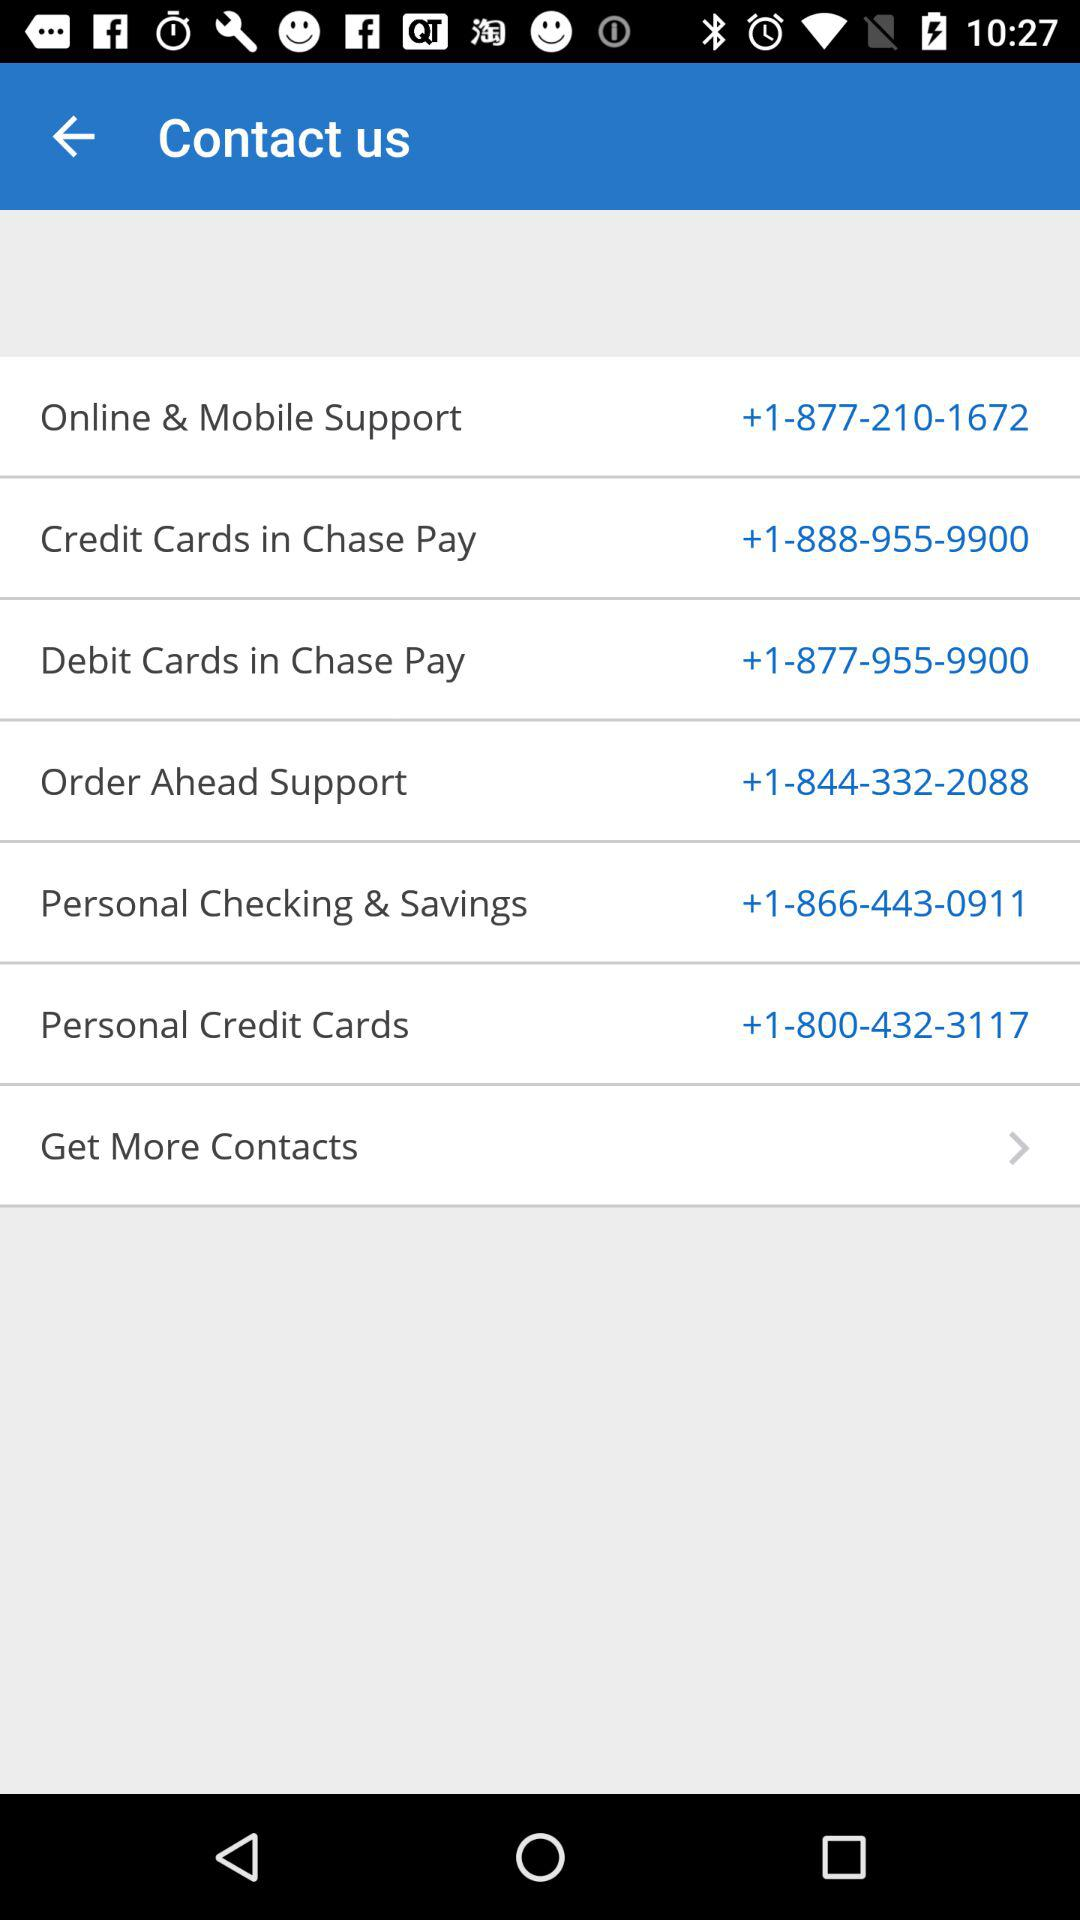What is the phone number for "Personal Credit Cards"? The phone number is +1-800-432-3117. 